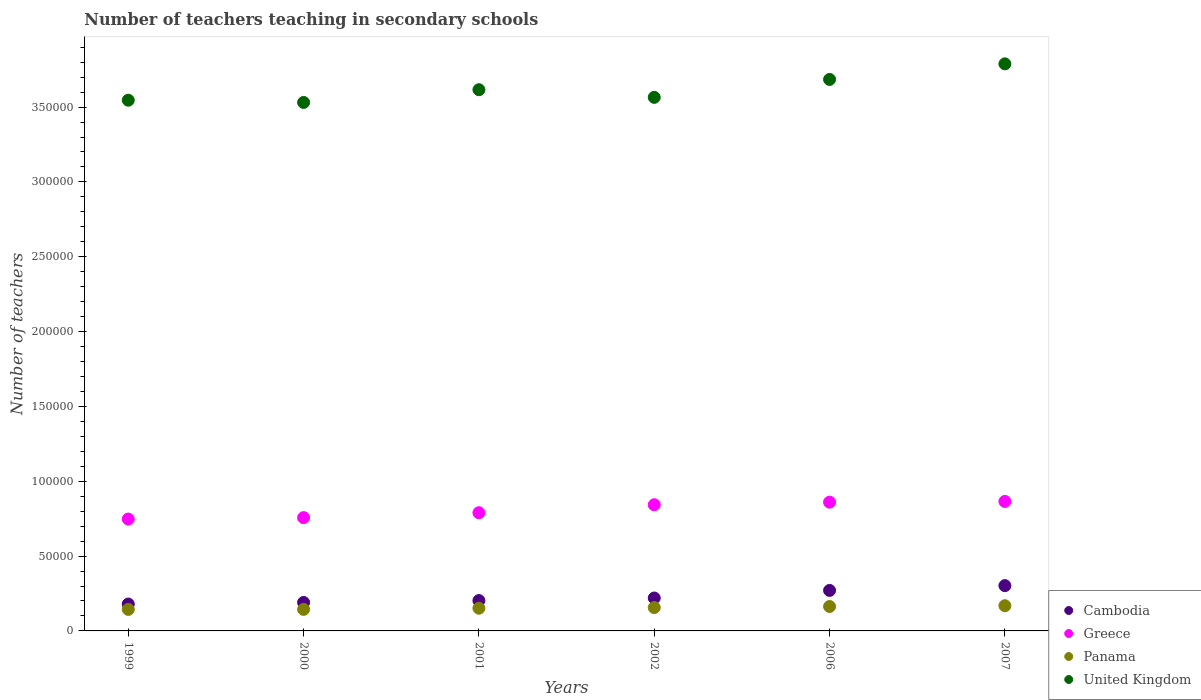What is the number of teachers teaching in secondary schools in United Kingdom in 2001?
Provide a succinct answer. 3.62e+05. Across all years, what is the maximum number of teachers teaching in secondary schools in United Kingdom?
Your answer should be very brief. 3.79e+05. Across all years, what is the minimum number of teachers teaching in secondary schools in Cambodia?
Ensure brevity in your answer.  1.80e+04. In which year was the number of teachers teaching in secondary schools in Greece maximum?
Your answer should be compact. 2007. What is the total number of teachers teaching in secondary schools in Cambodia in the graph?
Offer a terse response. 1.37e+05. What is the difference between the number of teachers teaching in secondary schools in Cambodia in 2000 and that in 2006?
Your answer should be compact. -8040. What is the difference between the number of teachers teaching in secondary schools in Greece in 1999 and the number of teachers teaching in secondary schools in Panama in 2001?
Your answer should be very brief. 5.96e+04. What is the average number of teachers teaching in secondary schools in Cambodia per year?
Keep it short and to the point. 2.28e+04. In the year 2007, what is the difference between the number of teachers teaching in secondary schools in Cambodia and number of teachers teaching in secondary schools in Greece?
Keep it short and to the point. -5.63e+04. What is the ratio of the number of teachers teaching in secondary schools in Cambodia in 2002 to that in 2007?
Give a very brief answer. 0.73. Is the difference between the number of teachers teaching in secondary schools in Cambodia in 1999 and 2007 greater than the difference between the number of teachers teaching in secondary schools in Greece in 1999 and 2007?
Your answer should be compact. No. What is the difference between the highest and the second highest number of teachers teaching in secondary schools in United Kingdom?
Make the answer very short. 1.04e+04. What is the difference between the highest and the lowest number of teachers teaching in secondary schools in United Kingdom?
Your answer should be compact. 2.58e+04. Is it the case that in every year, the sum of the number of teachers teaching in secondary schools in Panama and number of teachers teaching in secondary schools in United Kingdom  is greater than the number of teachers teaching in secondary schools in Cambodia?
Ensure brevity in your answer.  Yes. Does the number of teachers teaching in secondary schools in Cambodia monotonically increase over the years?
Make the answer very short. Yes. How many dotlines are there?
Provide a short and direct response. 4. How many years are there in the graph?
Your answer should be very brief. 6. What is the difference between two consecutive major ticks on the Y-axis?
Offer a terse response. 5.00e+04. Are the values on the major ticks of Y-axis written in scientific E-notation?
Offer a very short reply. No. Does the graph contain any zero values?
Offer a terse response. No. How many legend labels are there?
Your answer should be very brief. 4. What is the title of the graph?
Your answer should be compact. Number of teachers teaching in secondary schools. Does "Tunisia" appear as one of the legend labels in the graph?
Keep it short and to the point. No. What is the label or title of the X-axis?
Offer a terse response. Years. What is the label or title of the Y-axis?
Keep it short and to the point. Number of teachers. What is the Number of teachers in Cambodia in 1999?
Ensure brevity in your answer.  1.80e+04. What is the Number of teachers of Greece in 1999?
Your answer should be very brief. 7.47e+04. What is the Number of teachers of Panama in 1999?
Your response must be concise. 1.44e+04. What is the Number of teachers in United Kingdom in 1999?
Provide a short and direct response. 3.55e+05. What is the Number of teachers in Cambodia in 2000?
Your answer should be compact. 1.90e+04. What is the Number of teachers in Greece in 2000?
Ensure brevity in your answer.  7.57e+04. What is the Number of teachers of Panama in 2000?
Make the answer very short. 1.44e+04. What is the Number of teachers in United Kingdom in 2000?
Provide a short and direct response. 3.53e+05. What is the Number of teachers in Cambodia in 2001?
Give a very brief answer. 2.03e+04. What is the Number of teachers in Greece in 2001?
Your answer should be compact. 7.90e+04. What is the Number of teachers of Panama in 2001?
Give a very brief answer. 1.52e+04. What is the Number of teachers of United Kingdom in 2001?
Offer a terse response. 3.62e+05. What is the Number of teachers of Cambodia in 2002?
Your answer should be very brief. 2.20e+04. What is the Number of teachers in Greece in 2002?
Ensure brevity in your answer.  8.43e+04. What is the Number of teachers of Panama in 2002?
Make the answer very short. 1.56e+04. What is the Number of teachers of United Kingdom in 2002?
Keep it short and to the point. 3.56e+05. What is the Number of teachers of Cambodia in 2006?
Provide a short and direct response. 2.71e+04. What is the Number of teachers in Greece in 2006?
Provide a succinct answer. 8.60e+04. What is the Number of teachers of Panama in 2006?
Make the answer very short. 1.63e+04. What is the Number of teachers in United Kingdom in 2006?
Make the answer very short. 3.68e+05. What is the Number of teachers in Cambodia in 2007?
Your answer should be very brief. 3.03e+04. What is the Number of teachers of Greece in 2007?
Your answer should be very brief. 8.65e+04. What is the Number of teachers of Panama in 2007?
Offer a very short reply. 1.68e+04. What is the Number of teachers of United Kingdom in 2007?
Provide a short and direct response. 3.79e+05. Across all years, what is the maximum Number of teachers in Cambodia?
Give a very brief answer. 3.03e+04. Across all years, what is the maximum Number of teachers in Greece?
Provide a short and direct response. 8.65e+04. Across all years, what is the maximum Number of teachers of Panama?
Make the answer very short. 1.68e+04. Across all years, what is the maximum Number of teachers in United Kingdom?
Offer a terse response. 3.79e+05. Across all years, what is the minimum Number of teachers in Cambodia?
Keep it short and to the point. 1.80e+04. Across all years, what is the minimum Number of teachers in Greece?
Make the answer very short. 7.47e+04. Across all years, what is the minimum Number of teachers of Panama?
Your answer should be very brief. 1.44e+04. Across all years, what is the minimum Number of teachers in United Kingdom?
Make the answer very short. 3.53e+05. What is the total Number of teachers in Cambodia in the graph?
Provide a succinct answer. 1.37e+05. What is the total Number of teachers in Greece in the graph?
Provide a short and direct response. 4.86e+05. What is the total Number of teachers in Panama in the graph?
Offer a very short reply. 9.27e+04. What is the total Number of teachers in United Kingdom in the graph?
Give a very brief answer. 2.17e+06. What is the difference between the Number of teachers in Cambodia in 1999 and that in 2000?
Make the answer very short. -1059. What is the difference between the Number of teachers of Greece in 1999 and that in 2000?
Provide a succinct answer. -955. What is the difference between the Number of teachers in Panama in 1999 and that in 2000?
Your answer should be compact. -24. What is the difference between the Number of teachers in United Kingdom in 1999 and that in 2000?
Ensure brevity in your answer.  1498. What is the difference between the Number of teachers of Cambodia in 1999 and that in 2001?
Give a very brief answer. -2315. What is the difference between the Number of teachers in Greece in 1999 and that in 2001?
Your answer should be compact. -4229. What is the difference between the Number of teachers in Panama in 1999 and that in 2001?
Make the answer very short. -801. What is the difference between the Number of teachers in United Kingdom in 1999 and that in 2001?
Ensure brevity in your answer.  -7014. What is the difference between the Number of teachers in Cambodia in 1999 and that in 2002?
Make the answer very short. -4026. What is the difference between the Number of teachers in Greece in 1999 and that in 2002?
Your answer should be very brief. -9571. What is the difference between the Number of teachers in Panama in 1999 and that in 2002?
Your answer should be very brief. -1233. What is the difference between the Number of teachers of United Kingdom in 1999 and that in 2002?
Provide a short and direct response. -1903. What is the difference between the Number of teachers of Cambodia in 1999 and that in 2006?
Your answer should be compact. -9099. What is the difference between the Number of teachers of Greece in 1999 and that in 2006?
Offer a very short reply. -1.13e+04. What is the difference between the Number of teachers of Panama in 1999 and that in 2006?
Ensure brevity in your answer.  -1937. What is the difference between the Number of teachers in United Kingdom in 1999 and that in 2006?
Ensure brevity in your answer.  -1.39e+04. What is the difference between the Number of teachers in Cambodia in 1999 and that in 2007?
Offer a very short reply. -1.23e+04. What is the difference between the Number of teachers of Greece in 1999 and that in 2007?
Your response must be concise. -1.18e+04. What is the difference between the Number of teachers of Panama in 1999 and that in 2007?
Keep it short and to the point. -2467. What is the difference between the Number of teachers in United Kingdom in 1999 and that in 2007?
Ensure brevity in your answer.  -2.43e+04. What is the difference between the Number of teachers of Cambodia in 2000 and that in 2001?
Keep it short and to the point. -1256. What is the difference between the Number of teachers of Greece in 2000 and that in 2001?
Offer a very short reply. -3274. What is the difference between the Number of teachers in Panama in 2000 and that in 2001?
Your answer should be very brief. -777. What is the difference between the Number of teachers of United Kingdom in 2000 and that in 2001?
Give a very brief answer. -8512. What is the difference between the Number of teachers of Cambodia in 2000 and that in 2002?
Your answer should be compact. -2967. What is the difference between the Number of teachers of Greece in 2000 and that in 2002?
Give a very brief answer. -8616. What is the difference between the Number of teachers of Panama in 2000 and that in 2002?
Make the answer very short. -1209. What is the difference between the Number of teachers in United Kingdom in 2000 and that in 2002?
Your answer should be compact. -3401. What is the difference between the Number of teachers in Cambodia in 2000 and that in 2006?
Give a very brief answer. -8040. What is the difference between the Number of teachers of Greece in 2000 and that in 2006?
Your answer should be very brief. -1.03e+04. What is the difference between the Number of teachers in Panama in 2000 and that in 2006?
Offer a terse response. -1913. What is the difference between the Number of teachers in United Kingdom in 2000 and that in 2006?
Provide a succinct answer. -1.54e+04. What is the difference between the Number of teachers in Cambodia in 2000 and that in 2007?
Your response must be concise. -1.12e+04. What is the difference between the Number of teachers of Greece in 2000 and that in 2007?
Provide a short and direct response. -1.08e+04. What is the difference between the Number of teachers in Panama in 2000 and that in 2007?
Provide a short and direct response. -2443. What is the difference between the Number of teachers of United Kingdom in 2000 and that in 2007?
Your answer should be very brief. -2.58e+04. What is the difference between the Number of teachers in Cambodia in 2001 and that in 2002?
Provide a short and direct response. -1711. What is the difference between the Number of teachers of Greece in 2001 and that in 2002?
Make the answer very short. -5342. What is the difference between the Number of teachers of Panama in 2001 and that in 2002?
Offer a very short reply. -432. What is the difference between the Number of teachers in United Kingdom in 2001 and that in 2002?
Make the answer very short. 5111. What is the difference between the Number of teachers of Cambodia in 2001 and that in 2006?
Your answer should be compact. -6784. What is the difference between the Number of teachers in Greece in 2001 and that in 2006?
Keep it short and to the point. -7061. What is the difference between the Number of teachers of Panama in 2001 and that in 2006?
Provide a short and direct response. -1136. What is the difference between the Number of teachers in United Kingdom in 2001 and that in 2006?
Your response must be concise. -6865. What is the difference between the Number of teachers in Cambodia in 2001 and that in 2007?
Ensure brevity in your answer.  -9972. What is the difference between the Number of teachers in Greece in 2001 and that in 2007?
Ensure brevity in your answer.  -7550. What is the difference between the Number of teachers of Panama in 2001 and that in 2007?
Keep it short and to the point. -1666. What is the difference between the Number of teachers of United Kingdom in 2001 and that in 2007?
Your response must be concise. -1.73e+04. What is the difference between the Number of teachers of Cambodia in 2002 and that in 2006?
Provide a succinct answer. -5073. What is the difference between the Number of teachers of Greece in 2002 and that in 2006?
Provide a succinct answer. -1719. What is the difference between the Number of teachers of Panama in 2002 and that in 2006?
Make the answer very short. -704. What is the difference between the Number of teachers in United Kingdom in 2002 and that in 2006?
Provide a succinct answer. -1.20e+04. What is the difference between the Number of teachers in Cambodia in 2002 and that in 2007?
Offer a terse response. -8261. What is the difference between the Number of teachers of Greece in 2002 and that in 2007?
Give a very brief answer. -2208. What is the difference between the Number of teachers in Panama in 2002 and that in 2007?
Make the answer very short. -1234. What is the difference between the Number of teachers in United Kingdom in 2002 and that in 2007?
Make the answer very short. -2.24e+04. What is the difference between the Number of teachers of Cambodia in 2006 and that in 2007?
Ensure brevity in your answer.  -3188. What is the difference between the Number of teachers of Greece in 2006 and that in 2007?
Your response must be concise. -489. What is the difference between the Number of teachers in Panama in 2006 and that in 2007?
Keep it short and to the point. -530. What is the difference between the Number of teachers of United Kingdom in 2006 and that in 2007?
Make the answer very short. -1.04e+04. What is the difference between the Number of teachers in Cambodia in 1999 and the Number of teachers in Greece in 2000?
Offer a terse response. -5.77e+04. What is the difference between the Number of teachers in Cambodia in 1999 and the Number of teachers in Panama in 2000?
Your answer should be compact. 3567. What is the difference between the Number of teachers in Cambodia in 1999 and the Number of teachers in United Kingdom in 2000?
Give a very brief answer. -3.35e+05. What is the difference between the Number of teachers in Greece in 1999 and the Number of teachers in Panama in 2000?
Your answer should be very brief. 6.03e+04. What is the difference between the Number of teachers in Greece in 1999 and the Number of teachers in United Kingdom in 2000?
Offer a very short reply. -2.78e+05. What is the difference between the Number of teachers in Panama in 1999 and the Number of teachers in United Kingdom in 2000?
Ensure brevity in your answer.  -3.39e+05. What is the difference between the Number of teachers in Cambodia in 1999 and the Number of teachers in Greece in 2001?
Offer a very short reply. -6.10e+04. What is the difference between the Number of teachers of Cambodia in 1999 and the Number of teachers of Panama in 2001?
Ensure brevity in your answer.  2790. What is the difference between the Number of teachers of Cambodia in 1999 and the Number of teachers of United Kingdom in 2001?
Give a very brief answer. -3.44e+05. What is the difference between the Number of teachers of Greece in 1999 and the Number of teachers of Panama in 2001?
Keep it short and to the point. 5.96e+04. What is the difference between the Number of teachers of Greece in 1999 and the Number of teachers of United Kingdom in 2001?
Give a very brief answer. -2.87e+05. What is the difference between the Number of teachers in Panama in 1999 and the Number of teachers in United Kingdom in 2001?
Give a very brief answer. -3.47e+05. What is the difference between the Number of teachers in Cambodia in 1999 and the Number of teachers in Greece in 2002?
Offer a very short reply. -6.63e+04. What is the difference between the Number of teachers of Cambodia in 1999 and the Number of teachers of Panama in 2002?
Offer a terse response. 2358. What is the difference between the Number of teachers of Cambodia in 1999 and the Number of teachers of United Kingdom in 2002?
Provide a short and direct response. -3.39e+05. What is the difference between the Number of teachers of Greece in 1999 and the Number of teachers of Panama in 2002?
Offer a very short reply. 5.91e+04. What is the difference between the Number of teachers in Greece in 1999 and the Number of teachers in United Kingdom in 2002?
Provide a succinct answer. -2.82e+05. What is the difference between the Number of teachers in Panama in 1999 and the Number of teachers in United Kingdom in 2002?
Keep it short and to the point. -3.42e+05. What is the difference between the Number of teachers of Cambodia in 1999 and the Number of teachers of Greece in 2006?
Your answer should be compact. -6.81e+04. What is the difference between the Number of teachers in Cambodia in 1999 and the Number of teachers in Panama in 2006?
Offer a terse response. 1654. What is the difference between the Number of teachers of Cambodia in 1999 and the Number of teachers of United Kingdom in 2006?
Make the answer very short. -3.51e+05. What is the difference between the Number of teachers of Greece in 1999 and the Number of teachers of Panama in 2006?
Offer a terse response. 5.84e+04. What is the difference between the Number of teachers of Greece in 1999 and the Number of teachers of United Kingdom in 2006?
Your answer should be very brief. -2.94e+05. What is the difference between the Number of teachers of Panama in 1999 and the Number of teachers of United Kingdom in 2006?
Keep it short and to the point. -3.54e+05. What is the difference between the Number of teachers in Cambodia in 1999 and the Number of teachers in Greece in 2007?
Provide a succinct answer. -6.85e+04. What is the difference between the Number of teachers of Cambodia in 1999 and the Number of teachers of Panama in 2007?
Your response must be concise. 1124. What is the difference between the Number of teachers in Cambodia in 1999 and the Number of teachers in United Kingdom in 2007?
Ensure brevity in your answer.  -3.61e+05. What is the difference between the Number of teachers of Greece in 1999 and the Number of teachers of Panama in 2007?
Offer a very short reply. 5.79e+04. What is the difference between the Number of teachers of Greece in 1999 and the Number of teachers of United Kingdom in 2007?
Your answer should be very brief. -3.04e+05. What is the difference between the Number of teachers of Panama in 1999 and the Number of teachers of United Kingdom in 2007?
Ensure brevity in your answer.  -3.65e+05. What is the difference between the Number of teachers of Cambodia in 2000 and the Number of teachers of Greece in 2001?
Offer a very short reply. -5.99e+04. What is the difference between the Number of teachers of Cambodia in 2000 and the Number of teachers of Panama in 2001?
Your response must be concise. 3849. What is the difference between the Number of teachers of Cambodia in 2000 and the Number of teachers of United Kingdom in 2001?
Make the answer very short. -3.43e+05. What is the difference between the Number of teachers in Greece in 2000 and the Number of teachers in Panama in 2001?
Provide a short and direct response. 6.05e+04. What is the difference between the Number of teachers in Greece in 2000 and the Number of teachers in United Kingdom in 2001?
Give a very brief answer. -2.86e+05. What is the difference between the Number of teachers of Panama in 2000 and the Number of teachers of United Kingdom in 2001?
Your answer should be compact. -3.47e+05. What is the difference between the Number of teachers of Cambodia in 2000 and the Number of teachers of Greece in 2002?
Give a very brief answer. -6.53e+04. What is the difference between the Number of teachers in Cambodia in 2000 and the Number of teachers in Panama in 2002?
Your answer should be very brief. 3417. What is the difference between the Number of teachers of Cambodia in 2000 and the Number of teachers of United Kingdom in 2002?
Provide a succinct answer. -3.37e+05. What is the difference between the Number of teachers in Greece in 2000 and the Number of teachers in Panama in 2002?
Give a very brief answer. 6.01e+04. What is the difference between the Number of teachers of Greece in 2000 and the Number of teachers of United Kingdom in 2002?
Ensure brevity in your answer.  -2.81e+05. What is the difference between the Number of teachers in Panama in 2000 and the Number of teachers in United Kingdom in 2002?
Give a very brief answer. -3.42e+05. What is the difference between the Number of teachers of Cambodia in 2000 and the Number of teachers of Greece in 2006?
Provide a short and direct response. -6.70e+04. What is the difference between the Number of teachers in Cambodia in 2000 and the Number of teachers in Panama in 2006?
Provide a succinct answer. 2713. What is the difference between the Number of teachers in Cambodia in 2000 and the Number of teachers in United Kingdom in 2006?
Your answer should be very brief. -3.49e+05. What is the difference between the Number of teachers of Greece in 2000 and the Number of teachers of Panama in 2006?
Your response must be concise. 5.94e+04. What is the difference between the Number of teachers of Greece in 2000 and the Number of teachers of United Kingdom in 2006?
Give a very brief answer. -2.93e+05. What is the difference between the Number of teachers of Panama in 2000 and the Number of teachers of United Kingdom in 2006?
Your answer should be very brief. -3.54e+05. What is the difference between the Number of teachers in Cambodia in 2000 and the Number of teachers in Greece in 2007?
Your answer should be very brief. -6.75e+04. What is the difference between the Number of teachers in Cambodia in 2000 and the Number of teachers in Panama in 2007?
Provide a short and direct response. 2183. What is the difference between the Number of teachers in Cambodia in 2000 and the Number of teachers in United Kingdom in 2007?
Give a very brief answer. -3.60e+05. What is the difference between the Number of teachers in Greece in 2000 and the Number of teachers in Panama in 2007?
Your answer should be very brief. 5.88e+04. What is the difference between the Number of teachers in Greece in 2000 and the Number of teachers in United Kingdom in 2007?
Provide a short and direct response. -3.03e+05. What is the difference between the Number of teachers in Panama in 2000 and the Number of teachers in United Kingdom in 2007?
Provide a short and direct response. -3.64e+05. What is the difference between the Number of teachers in Cambodia in 2001 and the Number of teachers in Greece in 2002?
Your answer should be very brief. -6.40e+04. What is the difference between the Number of teachers in Cambodia in 2001 and the Number of teachers in Panama in 2002?
Ensure brevity in your answer.  4673. What is the difference between the Number of teachers in Cambodia in 2001 and the Number of teachers in United Kingdom in 2002?
Your response must be concise. -3.36e+05. What is the difference between the Number of teachers of Greece in 2001 and the Number of teachers of Panama in 2002?
Your answer should be compact. 6.34e+04. What is the difference between the Number of teachers of Greece in 2001 and the Number of teachers of United Kingdom in 2002?
Your answer should be very brief. -2.78e+05. What is the difference between the Number of teachers in Panama in 2001 and the Number of teachers in United Kingdom in 2002?
Keep it short and to the point. -3.41e+05. What is the difference between the Number of teachers of Cambodia in 2001 and the Number of teachers of Greece in 2006?
Your answer should be very brief. -6.57e+04. What is the difference between the Number of teachers of Cambodia in 2001 and the Number of teachers of Panama in 2006?
Offer a very short reply. 3969. What is the difference between the Number of teachers of Cambodia in 2001 and the Number of teachers of United Kingdom in 2006?
Provide a succinct answer. -3.48e+05. What is the difference between the Number of teachers in Greece in 2001 and the Number of teachers in Panama in 2006?
Offer a very short reply. 6.26e+04. What is the difference between the Number of teachers of Greece in 2001 and the Number of teachers of United Kingdom in 2006?
Your answer should be very brief. -2.90e+05. What is the difference between the Number of teachers of Panama in 2001 and the Number of teachers of United Kingdom in 2006?
Offer a very short reply. -3.53e+05. What is the difference between the Number of teachers of Cambodia in 2001 and the Number of teachers of Greece in 2007?
Make the answer very short. -6.62e+04. What is the difference between the Number of teachers of Cambodia in 2001 and the Number of teachers of Panama in 2007?
Keep it short and to the point. 3439. What is the difference between the Number of teachers in Cambodia in 2001 and the Number of teachers in United Kingdom in 2007?
Your response must be concise. -3.59e+05. What is the difference between the Number of teachers of Greece in 2001 and the Number of teachers of Panama in 2007?
Ensure brevity in your answer.  6.21e+04. What is the difference between the Number of teachers of Greece in 2001 and the Number of teachers of United Kingdom in 2007?
Offer a terse response. -3.00e+05. What is the difference between the Number of teachers of Panama in 2001 and the Number of teachers of United Kingdom in 2007?
Provide a short and direct response. -3.64e+05. What is the difference between the Number of teachers in Cambodia in 2002 and the Number of teachers in Greece in 2006?
Provide a short and direct response. -6.40e+04. What is the difference between the Number of teachers of Cambodia in 2002 and the Number of teachers of Panama in 2006?
Give a very brief answer. 5680. What is the difference between the Number of teachers in Cambodia in 2002 and the Number of teachers in United Kingdom in 2006?
Offer a terse response. -3.46e+05. What is the difference between the Number of teachers in Greece in 2002 and the Number of teachers in Panama in 2006?
Your answer should be compact. 6.80e+04. What is the difference between the Number of teachers of Greece in 2002 and the Number of teachers of United Kingdom in 2006?
Make the answer very short. -2.84e+05. What is the difference between the Number of teachers in Panama in 2002 and the Number of teachers in United Kingdom in 2006?
Your response must be concise. -3.53e+05. What is the difference between the Number of teachers of Cambodia in 2002 and the Number of teachers of Greece in 2007?
Your response must be concise. -6.45e+04. What is the difference between the Number of teachers in Cambodia in 2002 and the Number of teachers in Panama in 2007?
Offer a very short reply. 5150. What is the difference between the Number of teachers in Cambodia in 2002 and the Number of teachers in United Kingdom in 2007?
Keep it short and to the point. -3.57e+05. What is the difference between the Number of teachers in Greece in 2002 and the Number of teachers in Panama in 2007?
Make the answer very short. 6.75e+04. What is the difference between the Number of teachers of Greece in 2002 and the Number of teachers of United Kingdom in 2007?
Your answer should be very brief. -2.95e+05. What is the difference between the Number of teachers of Panama in 2002 and the Number of teachers of United Kingdom in 2007?
Offer a terse response. -3.63e+05. What is the difference between the Number of teachers in Cambodia in 2006 and the Number of teachers in Greece in 2007?
Provide a succinct answer. -5.94e+04. What is the difference between the Number of teachers of Cambodia in 2006 and the Number of teachers of Panama in 2007?
Ensure brevity in your answer.  1.02e+04. What is the difference between the Number of teachers of Cambodia in 2006 and the Number of teachers of United Kingdom in 2007?
Offer a very short reply. -3.52e+05. What is the difference between the Number of teachers of Greece in 2006 and the Number of teachers of Panama in 2007?
Make the answer very short. 6.92e+04. What is the difference between the Number of teachers of Greece in 2006 and the Number of teachers of United Kingdom in 2007?
Your response must be concise. -2.93e+05. What is the difference between the Number of teachers of Panama in 2006 and the Number of teachers of United Kingdom in 2007?
Keep it short and to the point. -3.63e+05. What is the average Number of teachers in Cambodia per year?
Your response must be concise. 2.28e+04. What is the average Number of teachers in Greece per year?
Give a very brief answer. 8.10e+04. What is the average Number of teachers in Panama per year?
Your answer should be compact. 1.55e+04. What is the average Number of teachers in United Kingdom per year?
Give a very brief answer. 3.62e+05. In the year 1999, what is the difference between the Number of teachers in Cambodia and Number of teachers in Greece?
Ensure brevity in your answer.  -5.68e+04. In the year 1999, what is the difference between the Number of teachers in Cambodia and Number of teachers in Panama?
Your response must be concise. 3591. In the year 1999, what is the difference between the Number of teachers of Cambodia and Number of teachers of United Kingdom?
Your response must be concise. -3.37e+05. In the year 1999, what is the difference between the Number of teachers of Greece and Number of teachers of Panama?
Ensure brevity in your answer.  6.04e+04. In the year 1999, what is the difference between the Number of teachers of Greece and Number of teachers of United Kingdom?
Give a very brief answer. -2.80e+05. In the year 1999, what is the difference between the Number of teachers of Panama and Number of teachers of United Kingdom?
Make the answer very short. -3.40e+05. In the year 2000, what is the difference between the Number of teachers of Cambodia and Number of teachers of Greece?
Provide a succinct answer. -5.67e+04. In the year 2000, what is the difference between the Number of teachers of Cambodia and Number of teachers of Panama?
Give a very brief answer. 4626. In the year 2000, what is the difference between the Number of teachers in Cambodia and Number of teachers in United Kingdom?
Offer a terse response. -3.34e+05. In the year 2000, what is the difference between the Number of teachers of Greece and Number of teachers of Panama?
Your answer should be compact. 6.13e+04. In the year 2000, what is the difference between the Number of teachers in Greece and Number of teachers in United Kingdom?
Give a very brief answer. -2.77e+05. In the year 2000, what is the difference between the Number of teachers of Panama and Number of teachers of United Kingdom?
Give a very brief answer. -3.39e+05. In the year 2001, what is the difference between the Number of teachers in Cambodia and Number of teachers in Greece?
Provide a short and direct response. -5.87e+04. In the year 2001, what is the difference between the Number of teachers of Cambodia and Number of teachers of Panama?
Make the answer very short. 5105. In the year 2001, what is the difference between the Number of teachers in Cambodia and Number of teachers in United Kingdom?
Provide a short and direct response. -3.41e+05. In the year 2001, what is the difference between the Number of teachers of Greece and Number of teachers of Panama?
Give a very brief answer. 6.38e+04. In the year 2001, what is the difference between the Number of teachers of Greece and Number of teachers of United Kingdom?
Your answer should be compact. -2.83e+05. In the year 2001, what is the difference between the Number of teachers of Panama and Number of teachers of United Kingdom?
Keep it short and to the point. -3.46e+05. In the year 2002, what is the difference between the Number of teachers in Cambodia and Number of teachers in Greece?
Your answer should be very brief. -6.23e+04. In the year 2002, what is the difference between the Number of teachers in Cambodia and Number of teachers in Panama?
Make the answer very short. 6384. In the year 2002, what is the difference between the Number of teachers of Cambodia and Number of teachers of United Kingdom?
Give a very brief answer. -3.35e+05. In the year 2002, what is the difference between the Number of teachers in Greece and Number of teachers in Panama?
Your answer should be very brief. 6.87e+04. In the year 2002, what is the difference between the Number of teachers in Greece and Number of teachers in United Kingdom?
Offer a terse response. -2.72e+05. In the year 2002, what is the difference between the Number of teachers of Panama and Number of teachers of United Kingdom?
Provide a short and direct response. -3.41e+05. In the year 2006, what is the difference between the Number of teachers of Cambodia and Number of teachers of Greece?
Your answer should be compact. -5.90e+04. In the year 2006, what is the difference between the Number of teachers in Cambodia and Number of teachers in Panama?
Your response must be concise. 1.08e+04. In the year 2006, what is the difference between the Number of teachers of Cambodia and Number of teachers of United Kingdom?
Ensure brevity in your answer.  -3.41e+05. In the year 2006, what is the difference between the Number of teachers in Greece and Number of teachers in Panama?
Your answer should be compact. 6.97e+04. In the year 2006, what is the difference between the Number of teachers in Greece and Number of teachers in United Kingdom?
Keep it short and to the point. -2.82e+05. In the year 2006, what is the difference between the Number of teachers in Panama and Number of teachers in United Kingdom?
Your response must be concise. -3.52e+05. In the year 2007, what is the difference between the Number of teachers in Cambodia and Number of teachers in Greece?
Your answer should be compact. -5.63e+04. In the year 2007, what is the difference between the Number of teachers of Cambodia and Number of teachers of Panama?
Keep it short and to the point. 1.34e+04. In the year 2007, what is the difference between the Number of teachers in Cambodia and Number of teachers in United Kingdom?
Make the answer very short. -3.49e+05. In the year 2007, what is the difference between the Number of teachers in Greece and Number of teachers in Panama?
Provide a succinct answer. 6.97e+04. In the year 2007, what is the difference between the Number of teachers in Greece and Number of teachers in United Kingdom?
Offer a terse response. -2.92e+05. In the year 2007, what is the difference between the Number of teachers in Panama and Number of teachers in United Kingdom?
Your answer should be compact. -3.62e+05. What is the ratio of the Number of teachers in Greece in 1999 to that in 2000?
Make the answer very short. 0.99. What is the ratio of the Number of teachers in Panama in 1999 to that in 2000?
Provide a short and direct response. 1. What is the ratio of the Number of teachers of Cambodia in 1999 to that in 2001?
Ensure brevity in your answer.  0.89. What is the ratio of the Number of teachers in Greece in 1999 to that in 2001?
Your answer should be very brief. 0.95. What is the ratio of the Number of teachers in Panama in 1999 to that in 2001?
Give a very brief answer. 0.95. What is the ratio of the Number of teachers of United Kingdom in 1999 to that in 2001?
Your response must be concise. 0.98. What is the ratio of the Number of teachers of Cambodia in 1999 to that in 2002?
Ensure brevity in your answer.  0.82. What is the ratio of the Number of teachers of Greece in 1999 to that in 2002?
Make the answer very short. 0.89. What is the ratio of the Number of teachers of Panama in 1999 to that in 2002?
Keep it short and to the point. 0.92. What is the ratio of the Number of teachers of United Kingdom in 1999 to that in 2002?
Provide a short and direct response. 0.99. What is the ratio of the Number of teachers in Cambodia in 1999 to that in 2006?
Offer a very short reply. 0.66. What is the ratio of the Number of teachers of Greece in 1999 to that in 2006?
Provide a short and direct response. 0.87. What is the ratio of the Number of teachers of Panama in 1999 to that in 2006?
Give a very brief answer. 0.88. What is the ratio of the Number of teachers of United Kingdom in 1999 to that in 2006?
Ensure brevity in your answer.  0.96. What is the ratio of the Number of teachers in Cambodia in 1999 to that in 2007?
Ensure brevity in your answer.  0.59. What is the ratio of the Number of teachers of Greece in 1999 to that in 2007?
Offer a very short reply. 0.86. What is the ratio of the Number of teachers in Panama in 1999 to that in 2007?
Make the answer very short. 0.85. What is the ratio of the Number of teachers in United Kingdom in 1999 to that in 2007?
Keep it short and to the point. 0.94. What is the ratio of the Number of teachers in Cambodia in 2000 to that in 2001?
Offer a terse response. 0.94. What is the ratio of the Number of teachers of Greece in 2000 to that in 2001?
Provide a succinct answer. 0.96. What is the ratio of the Number of teachers of Panama in 2000 to that in 2001?
Provide a succinct answer. 0.95. What is the ratio of the Number of teachers in United Kingdom in 2000 to that in 2001?
Keep it short and to the point. 0.98. What is the ratio of the Number of teachers of Cambodia in 2000 to that in 2002?
Ensure brevity in your answer.  0.87. What is the ratio of the Number of teachers of Greece in 2000 to that in 2002?
Your answer should be very brief. 0.9. What is the ratio of the Number of teachers of Panama in 2000 to that in 2002?
Your answer should be compact. 0.92. What is the ratio of the Number of teachers of United Kingdom in 2000 to that in 2002?
Keep it short and to the point. 0.99. What is the ratio of the Number of teachers of Cambodia in 2000 to that in 2006?
Ensure brevity in your answer.  0.7. What is the ratio of the Number of teachers of Greece in 2000 to that in 2006?
Ensure brevity in your answer.  0.88. What is the ratio of the Number of teachers in Panama in 2000 to that in 2006?
Offer a very short reply. 0.88. What is the ratio of the Number of teachers in Cambodia in 2000 to that in 2007?
Offer a terse response. 0.63. What is the ratio of the Number of teachers in Greece in 2000 to that in 2007?
Keep it short and to the point. 0.87. What is the ratio of the Number of teachers in Panama in 2000 to that in 2007?
Make the answer very short. 0.85. What is the ratio of the Number of teachers in United Kingdom in 2000 to that in 2007?
Provide a succinct answer. 0.93. What is the ratio of the Number of teachers of Cambodia in 2001 to that in 2002?
Your answer should be compact. 0.92. What is the ratio of the Number of teachers of Greece in 2001 to that in 2002?
Provide a succinct answer. 0.94. What is the ratio of the Number of teachers of Panama in 2001 to that in 2002?
Offer a very short reply. 0.97. What is the ratio of the Number of teachers of United Kingdom in 2001 to that in 2002?
Your answer should be very brief. 1.01. What is the ratio of the Number of teachers of Cambodia in 2001 to that in 2006?
Keep it short and to the point. 0.75. What is the ratio of the Number of teachers in Greece in 2001 to that in 2006?
Offer a terse response. 0.92. What is the ratio of the Number of teachers in Panama in 2001 to that in 2006?
Ensure brevity in your answer.  0.93. What is the ratio of the Number of teachers of United Kingdom in 2001 to that in 2006?
Your answer should be very brief. 0.98. What is the ratio of the Number of teachers of Cambodia in 2001 to that in 2007?
Keep it short and to the point. 0.67. What is the ratio of the Number of teachers of Greece in 2001 to that in 2007?
Your answer should be compact. 0.91. What is the ratio of the Number of teachers in Panama in 2001 to that in 2007?
Your answer should be compact. 0.9. What is the ratio of the Number of teachers of United Kingdom in 2001 to that in 2007?
Your answer should be very brief. 0.95. What is the ratio of the Number of teachers of Cambodia in 2002 to that in 2006?
Your answer should be compact. 0.81. What is the ratio of the Number of teachers of Greece in 2002 to that in 2006?
Your answer should be compact. 0.98. What is the ratio of the Number of teachers of Panama in 2002 to that in 2006?
Your response must be concise. 0.96. What is the ratio of the Number of teachers in United Kingdom in 2002 to that in 2006?
Provide a short and direct response. 0.97. What is the ratio of the Number of teachers in Cambodia in 2002 to that in 2007?
Your answer should be compact. 0.73. What is the ratio of the Number of teachers in Greece in 2002 to that in 2007?
Provide a succinct answer. 0.97. What is the ratio of the Number of teachers of Panama in 2002 to that in 2007?
Provide a succinct answer. 0.93. What is the ratio of the Number of teachers in United Kingdom in 2002 to that in 2007?
Give a very brief answer. 0.94. What is the ratio of the Number of teachers in Cambodia in 2006 to that in 2007?
Provide a succinct answer. 0.89. What is the ratio of the Number of teachers in Panama in 2006 to that in 2007?
Ensure brevity in your answer.  0.97. What is the ratio of the Number of teachers in United Kingdom in 2006 to that in 2007?
Give a very brief answer. 0.97. What is the difference between the highest and the second highest Number of teachers in Cambodia?
Your response must be concise. 3188. What is the difference between the highest and the second highest Number of teachers in Greece?
Your answer should be compact. 489. What is the difference between the highest and the second highest Number of teachers in Panama?
Provide a succinct answer. 530. What is the difference between the highest and the second highest Number of teachers of United Kingdom?
Offer a very short reply. 1.04e+04. What is the difference between the highest and the lowest Number of teachers in Cambodia?
Offer a very short reply. 1.23e+04. What is the difference between the highest and the lowest Number of teachers in Greece?
Your answer should be very brief. 1.18e+04. What is the difference between the highest and the lowest Number of teachers in Panama?
Offer a terse response. 2467. What is the difference between the highest and the lowest Number of teachers of United Kingdom?
Your answer should be very brief. 2.58e+04. 